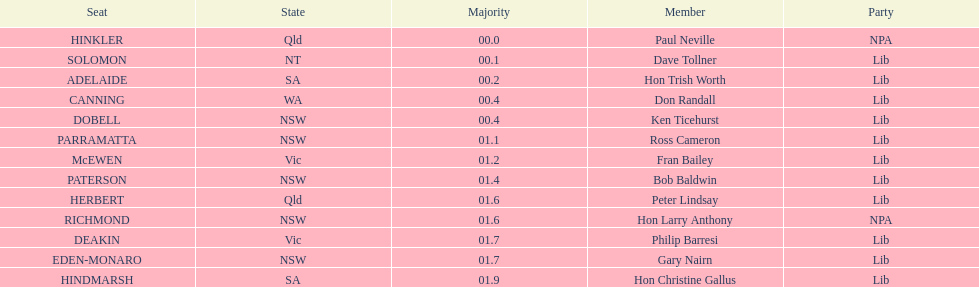Which member follows after hon trish worth? Don Randall. 